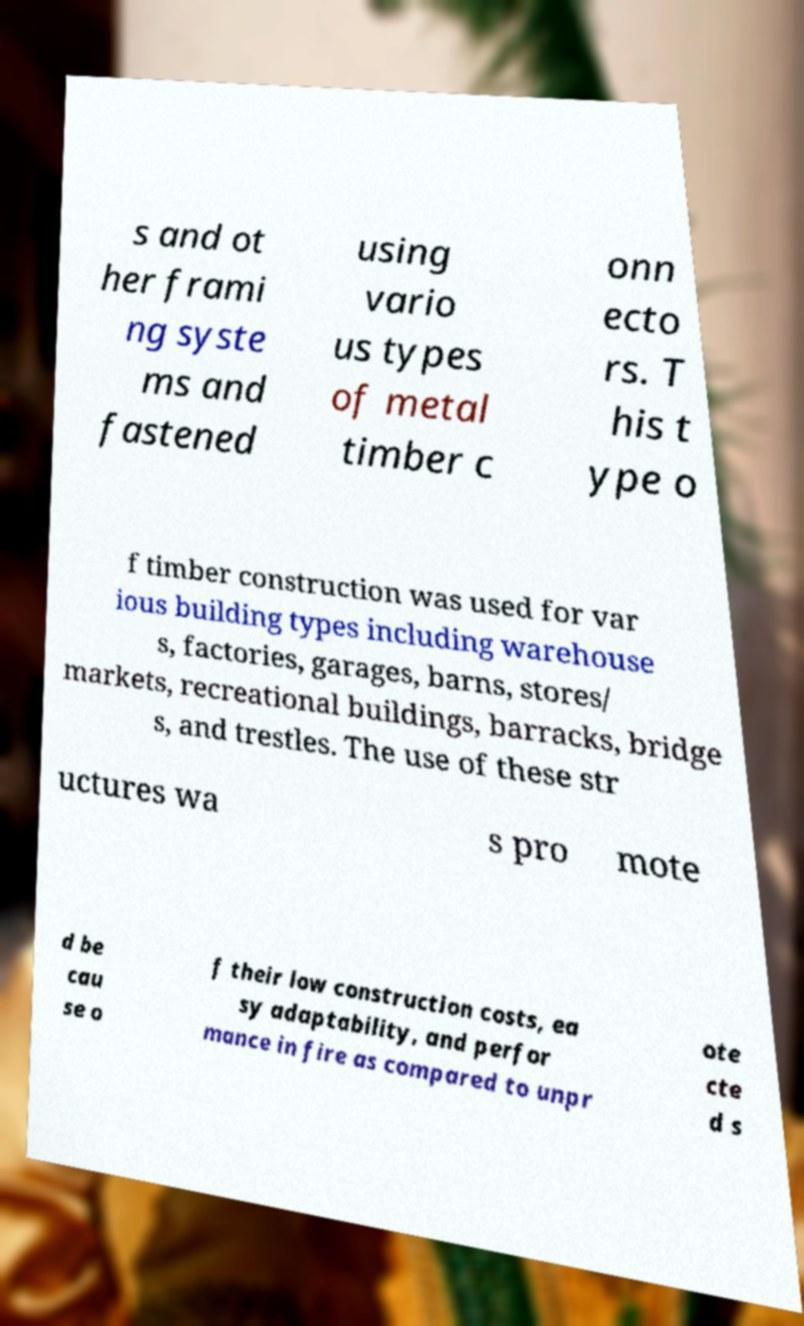Could you extract and type out the text from this image? s and ot her frami ng syste ms and fastened using vario us types of metal timber c onn ecto rs. T his t ype o f timber construction was used for var ious building types including warehouse s, factories, garages, barns, stores/ markets, recreational buildings, barracks, bridge s, and trestles. The use of these str uctures wa s pro mote d be cau se o f their low construction costs, ea sy adaptability, and perfor mance in fire as compared to unpr ote cte d s 